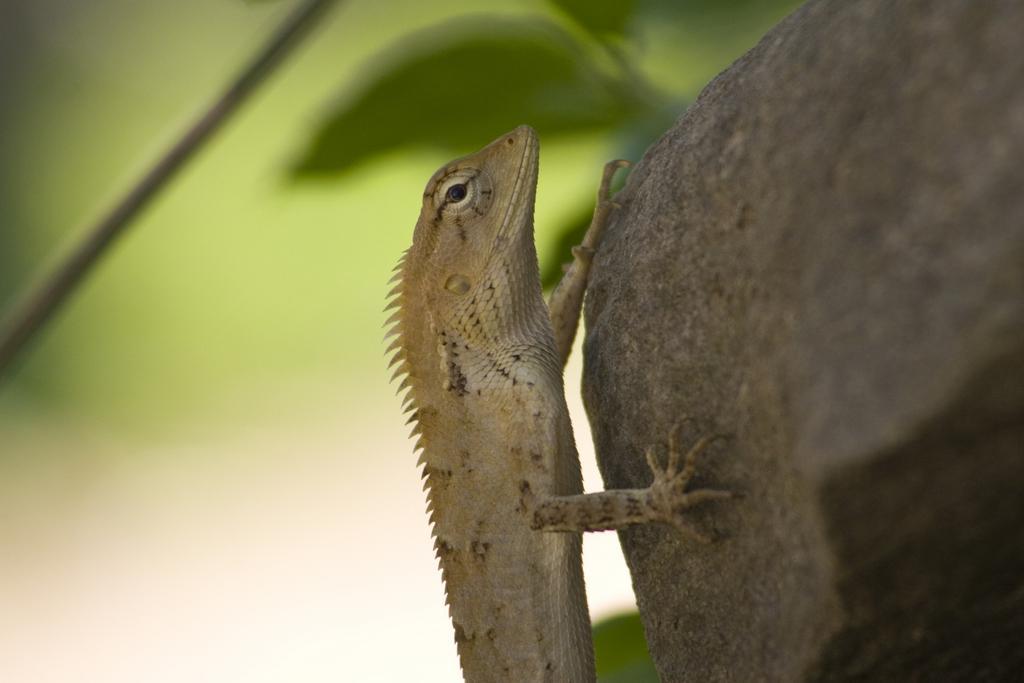How would you summarize this image in a sentence or two? In this image I can see a stone on the right side and on it I can see a lizard. In the background I can see few leaves and I can also see this image is little bit blurry. 